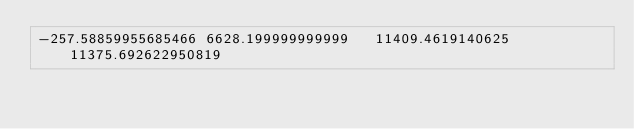<code> <loc_0><loc_0><loc_500><loc_500><_SQL_>-257.58859955685466	6628.199999999999	11409.4619140625	11375.692622950819</code> 